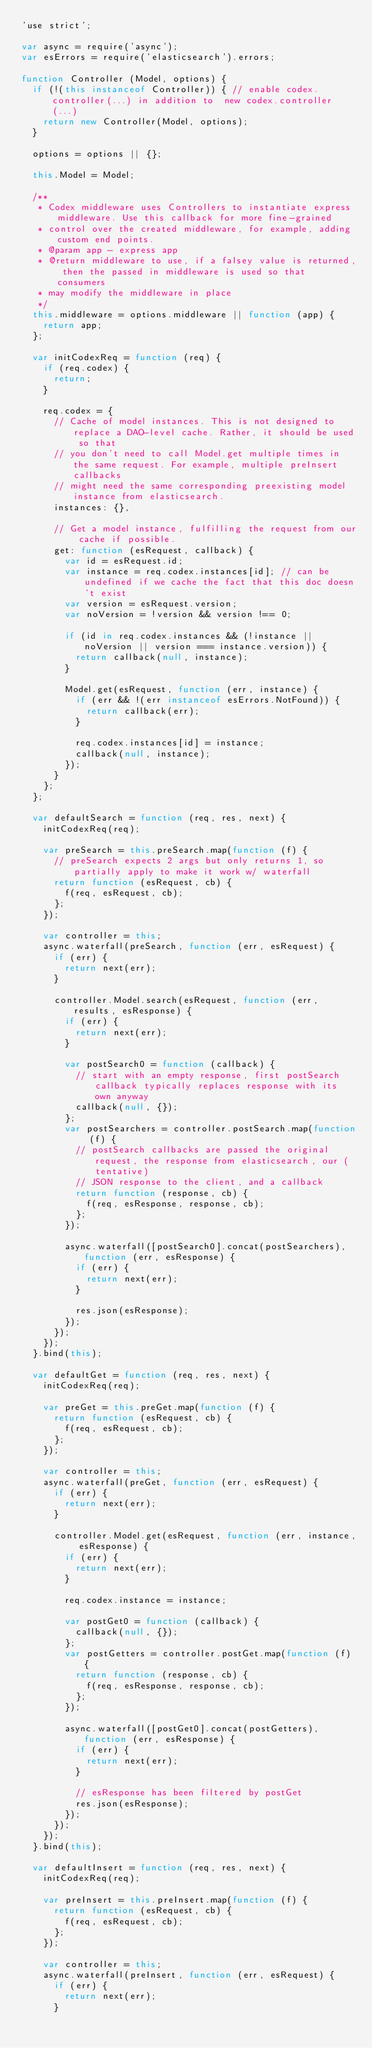<code> <loc_0><loc_0><loc_500><loc_500><_JavaScript_>'use strict';

var async = require('async');
var esErrors = require('elasticsearch').errors;

function Controller (Model, options) {
  if (!(this instanceof Controller)) { // enable codex.controller(...) in addition to  new codex.controller(...)
    return new Controller(Model, options);
  }

  options = options || {};

  this.Model = Model;

  /**
   * Codex middleware uses Controllers to instantiate express middleware. Use this callback for more fine-grained
   * control over the created middleware, for example, adding custom end points.
   * @param app - express app
   * @return middleware to use, if a falsey value is returned, then the passed in middleware is used so that consumers
   * may modify the middleware in place
   */
  this.middleware = options.middleware || function (app) {
    return app;
  };

  var initCodexReq = function (req) {
    if (req.codex) {
      return;
    }

    req.codex = {
      // Cache of model instances. This is not designed to replace a DAO-level cache. Rather, it should be used so that
      // you don't need to call Model.get multiple times in the same request. For example, multiple preInsert callbacks
      // might need the same corresponding preexisting model instance from elasticsearch.
      instances: {},

      // Get a model instance, fulfilling the request from our cache if possible.
      get: function (esRequest, callback) {
        var id = esRequest.id;
        var instance = req.codex.instances[id]; // can be undefined if we cache the fact that this doc doesn't exist
        var version = esRequest.version;
        var noVersion = !version && version !== 0;

        if (id in req.codex.instances && (!instance || noVersion || version === instance.version)) {
          return callback(null, instance);
        }

        Model.get(esRequest, function (err, instance) {
          if (err && !(err instanceof esErrors.NotFound)) {
            return callback(err);
          }

          req.codex.instances[id] = instance;
          callback(null, instance);
        });
      }
    };
  };

  var defaultSearch = function (req, res, next) {
    initCodexReq(req);

    var preSearch = this.preSearch.map(function (f) {
      // preSearch expects 2 args but only returns 1, so partially apply to make it work w/ waterfall
      return function (esRequest, cb) {
        f(req, esRequest, cb);
      };
    });

    var controller = this;
    async.waterfall(preSearch, function (err, esRequest) {
      if (err) {
        return next(err);
      }

      controller.Model.search(esRequest, function (err, results, esResponse) {
        if (err) {
          return next(err);
        }

        var postSearch0 = function (callback) {
          // start with an empty response, first postSearch callback typically replaces response with its own anyway
          callback(null, {});
        };
        var postSearchers = controller.postSearch.map(function (f) {
          // postSearch callbacks are passed the original request, the response from elasticsearch, our (tentative)
          // JSON response to the client, and a callback
          return function (response, cb) {
            f(req, esResponse, response, cb);
          };
        });

        async.waterfall([postSearch0].concat(postSearchers), function (err, esResponse) {
          if (err) {
            return next(err);
          }

          res.json(esResponse);
        });
      });
    });
  }.bind(this);

  var defaultGet = function (req, res, next) {
    initCodexReq(req);

    var preGet = this.preGet.map(function (f) {
      return function (esRequest, cb) {
        f(req, esRequest, cb);
      };
    });

    var controller = this;
    async.waterfall(preGet, function (err, esRequest) {
      if (err) {
        return next(err);
      }

      controller.Model.get(esRequest, function (err, instance, esResponse) {
        if (err) {
          return next(err);
        }

        req.codex.instance = instance;

        var postGet0 = function (callback) {
          callback(null, {});
        };
        var postGetters = controller.postGet.map(function (f) {
          return function (response, cb) {
            f(req, esResponse, response, cb);
          };
        });

        async.waterfall([postGet0].concat(postGetters), function (err, esResponse) {
          if (err) {
            return next(err);
          }

          // esResponse has been filtered by postGet
          res.json(esResponse);
        });
      });
    });
  }.bind(this);

  var defaultInsert = function (req, res, next) {
    initCodexReq(req);

    var preInsert = this.preInsert.map(function (f) {
      return function (esRequest, cb) {
        f(req, esRequest, cb);
      };
    });

    var controller = this;
    async.waterfall(preInsert, function (err, esRequest) {
      if (err) {
        return next(err);
      }
</code> 